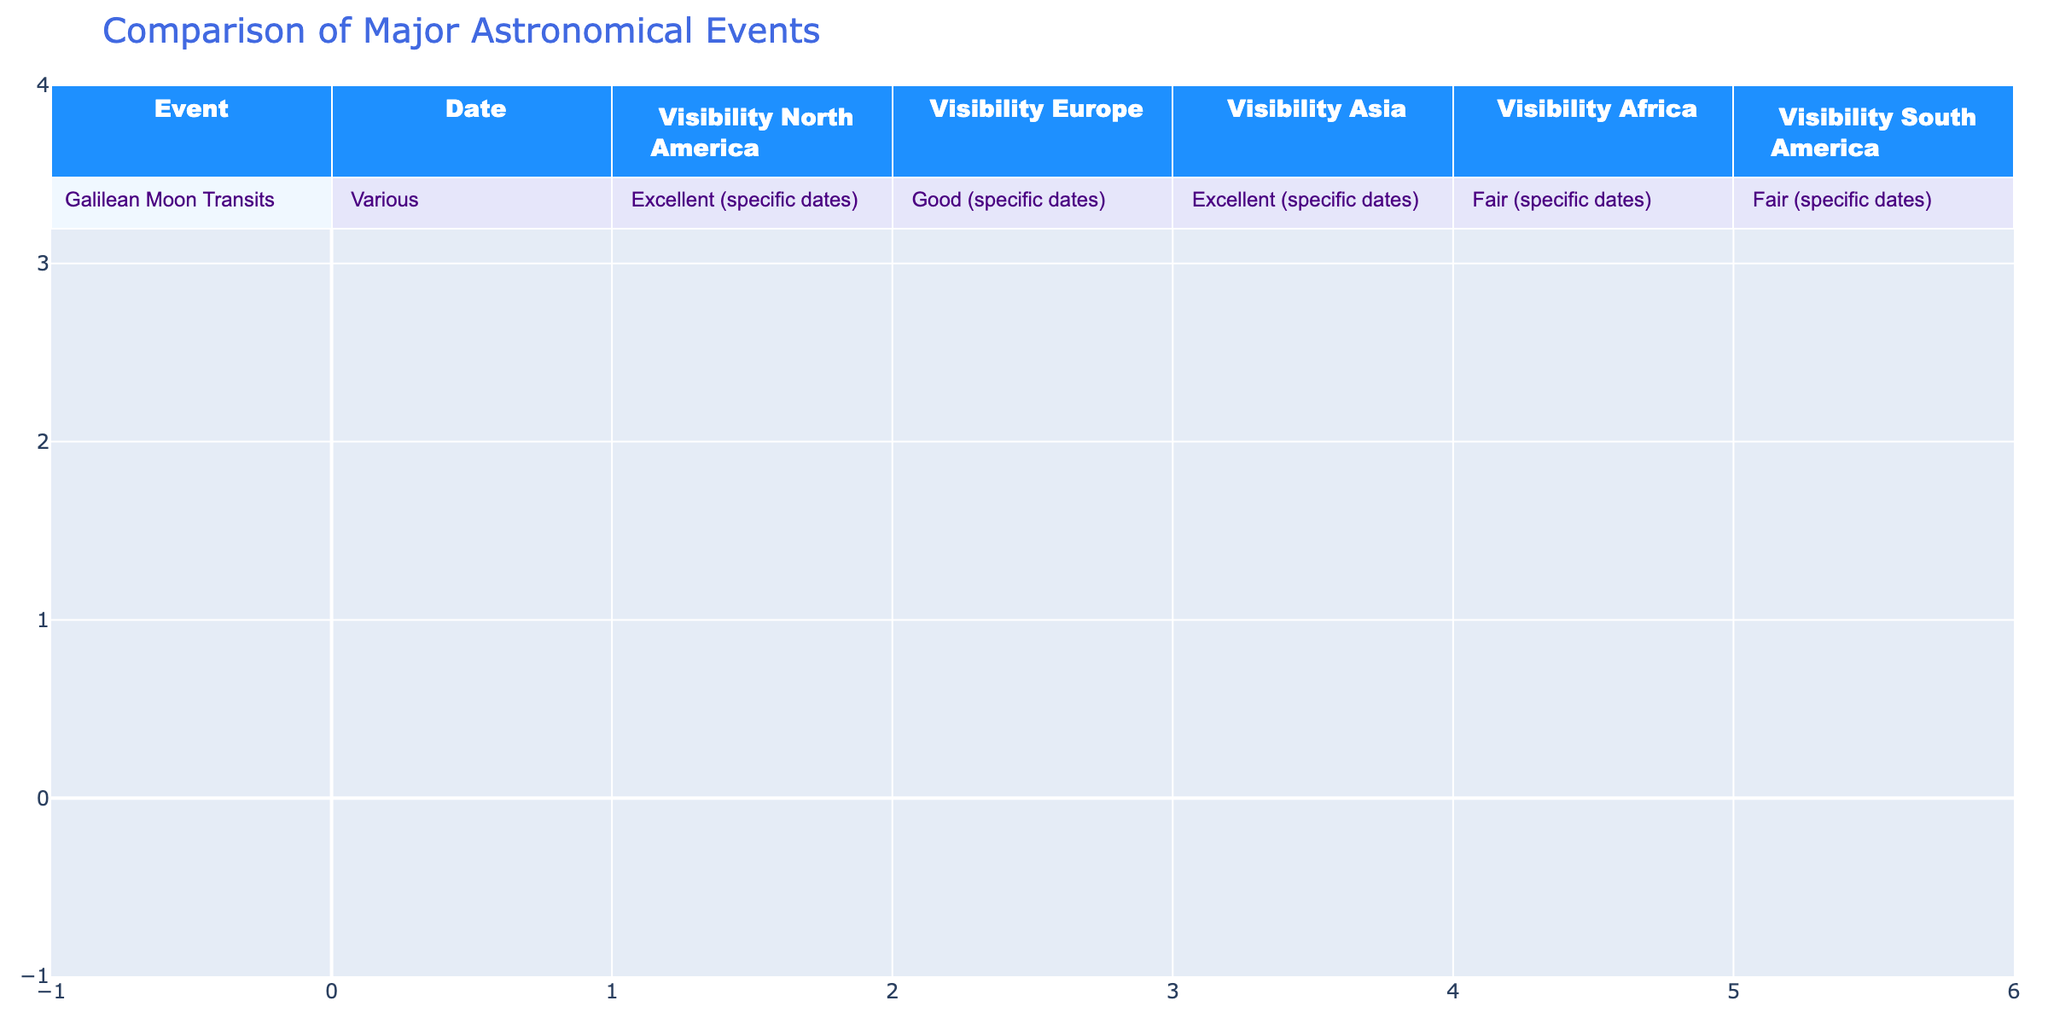What is the visibility of the Galilean Moon Transits in North America? The table shows that the visibility for the Galilean Moon Transits in North America is 'Excellent.'
Answer: Excellent Which continent has 'Fair' visibility for the Galilean Moon Transits? According to the table, both Africa and South America have 'Fair' visibility for the Galilean Moon Transits.
Answer: Africa and South America Is the visibility from Europe 'Good' for the Galilean Moon Transits? The table states that the visibility from Europe is 'Good,' confirming that the statement is true.
Answer: Yes Which continent has the best overall visibility for the Galilean Moon Transits? North America and Asia both have 'Excellent' visibility, which is the best rating in the table. Therefore, the best overall visibility is 'Excellent' from those continents.
Answer: North America and Asia If we compare Africa and South America, which has better visibility? The visibility in Africa is rated as 'Fair,' while South America also has 'Fair.' Therefore, there is no difference in visibility between the two continents in this case.
Answer: Neither, they are the same What is the combined visibility rating for Asia and South America? Asia has 'Excellent' visibility, and South America has 'Fair' visibility. Together, they do not have a consistent rating that combines these categories meaningfully as one is excellent, the other fair. Hence, for visibility, it is not straightforward to combine these.
Answer: Cannot be combined meaningfully In how many continents is the visibility for the Galilean Moon Transits rated as 'Excellent'? The table indicates that the visibility is 'Excellent' in two continents: North America and Asia. This counts as 2 continents with 'Excellent' visibility.
Answer: 2 